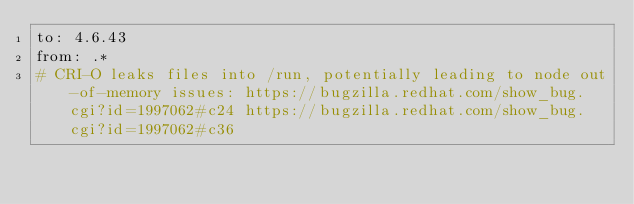<code> <loc_0><loc_0><loc_500><loc_500><_YAML_>to: 4.6.43
from: .*
# CRI-O leaks files into /run, potentially leading to node out-of-memory issues: https://bugzilla.redhat.com/show_bug.cgi?id=1997062#c24 https://bugzilla.redhat.com/show_bug.cgi?id=1997062#c36
</code> 